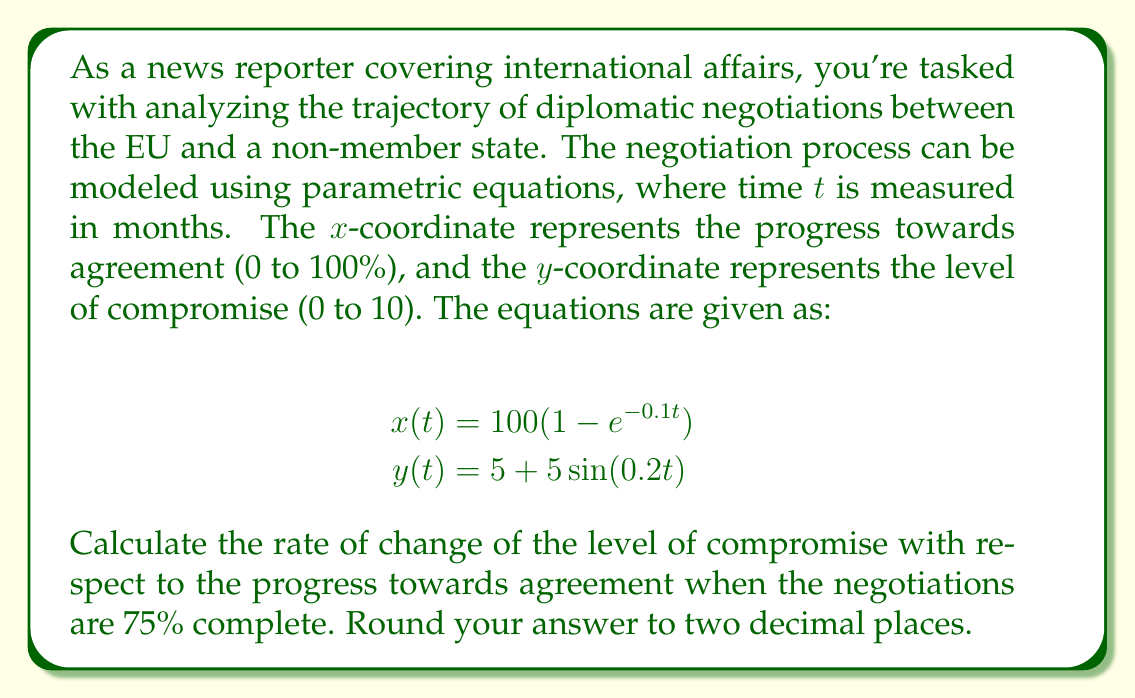Can you solve this math problem? To solve this problem, we'll follow these steps:

1) First, we need to find the time t when the progress (x) is 75%. We can do this by solving the equation:

   $$75 = 100(1 - e^{-0.1t})$$

2) Solving for t:
   $$0.75 = 1 - e^{-0.1t}$$
   $$e^{-0.1t} = 0.25$$
   $$-0.1t = \ln(0.25)$$
   $$t = -\frac{\ln(0.25)}{0.1} \approx 13.86$$

3) Now we need to find $\frac{dy}{dx}$. We can do this using the chain rule:

   $$\frac{dy}{dx} = \frac{dy/dt}{dx/dt}$$

4) Calculate $\frac{dx}{dt}$:
   $$\frac{dx}{dt} = 100(0.1e^{-0.1t})$$

5) Calculate $\frac{dy}{dt}$:
   $$\frac{dy}{dt} = 5(0.2)\cos(0.2t)$$

6) Now we can calculate $\frac{dy}{dx}$:
   $$\frac{dy}{dx} = \frac{5(0.2)\cos(0.2t)}{100(0.1e^{-0.1t})}$$

7) Substitute t ≈ 13.86:
   $$\frac{dy}{dx} = \frac{5(0.2)\cos(0.2(13.86))}{100(0.1e^{-0.1(13.86)})} \approx 0.4$$
Answer: The rate of change of the level of compromise with respect to the progress towards agreement when the negotiations are 75% complete is approximately 0.40. 